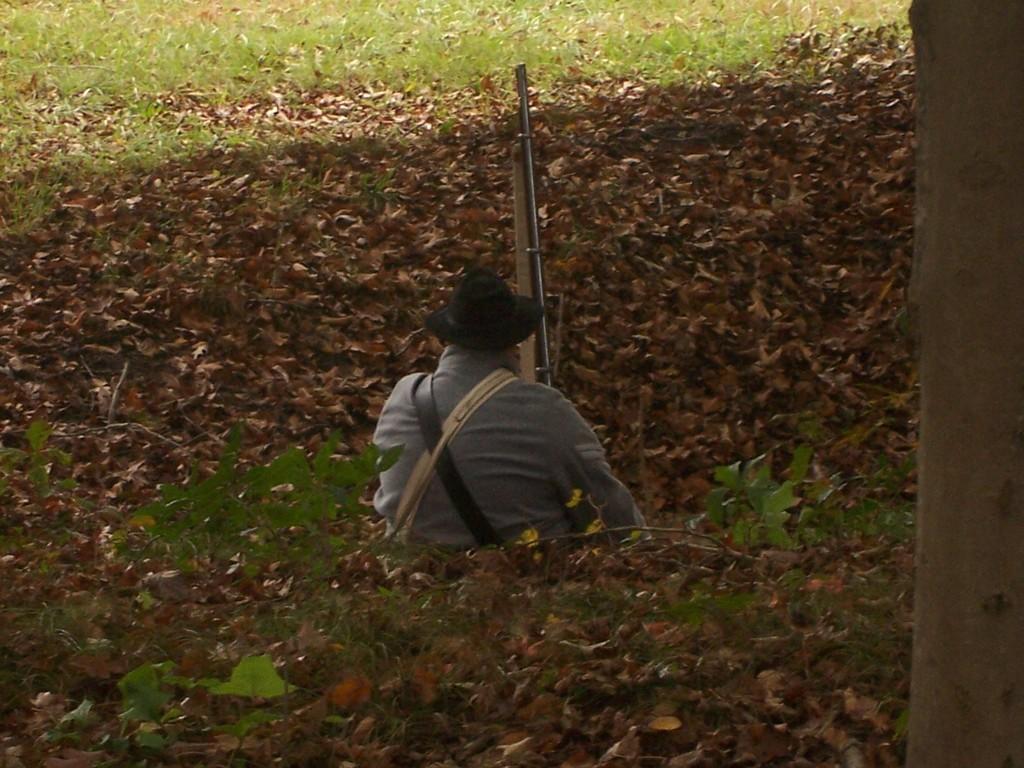Could you give a brief overview of what you see in this image? There is a person wearing hat is holding a gun. On the ground there is grass, plants and dried leaves. On the right side we can see a trunk of a tree. 